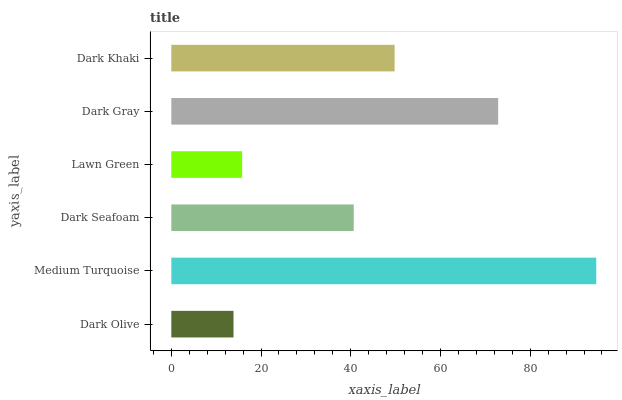Is Dark Olive the minimum?
Answer yes or no. Yes. Is Medium Turquoise the maximum?
Answer yes or no. Yes. Is Dark Seafoam the minimum?
Answer yes or no. No. Is Dark Seafoam the maximum?
Answer yes or no. No. Is Medium Turquoise greater than Dark Seafoam?
Answer yes or no. Yes. Is Dark Seafoam less than Medium Turquoise?
Answer yes or no. Yes. Is Dark Seafoam greater than Medium Turquoise?
Answer yes or no. No. Is Medium Turquoise less than Dark Seafoam?
Answer yes or no. No. Is Dark Khaki the high median?
Answer yes or no. Yes. Is Dark Seafoam the low median?
Answer yes or no. Yes. Is Dark Gray the high median?
Answer yes or no. No. Is Medium Turquoise the low median?
Answer yes or no. No. 